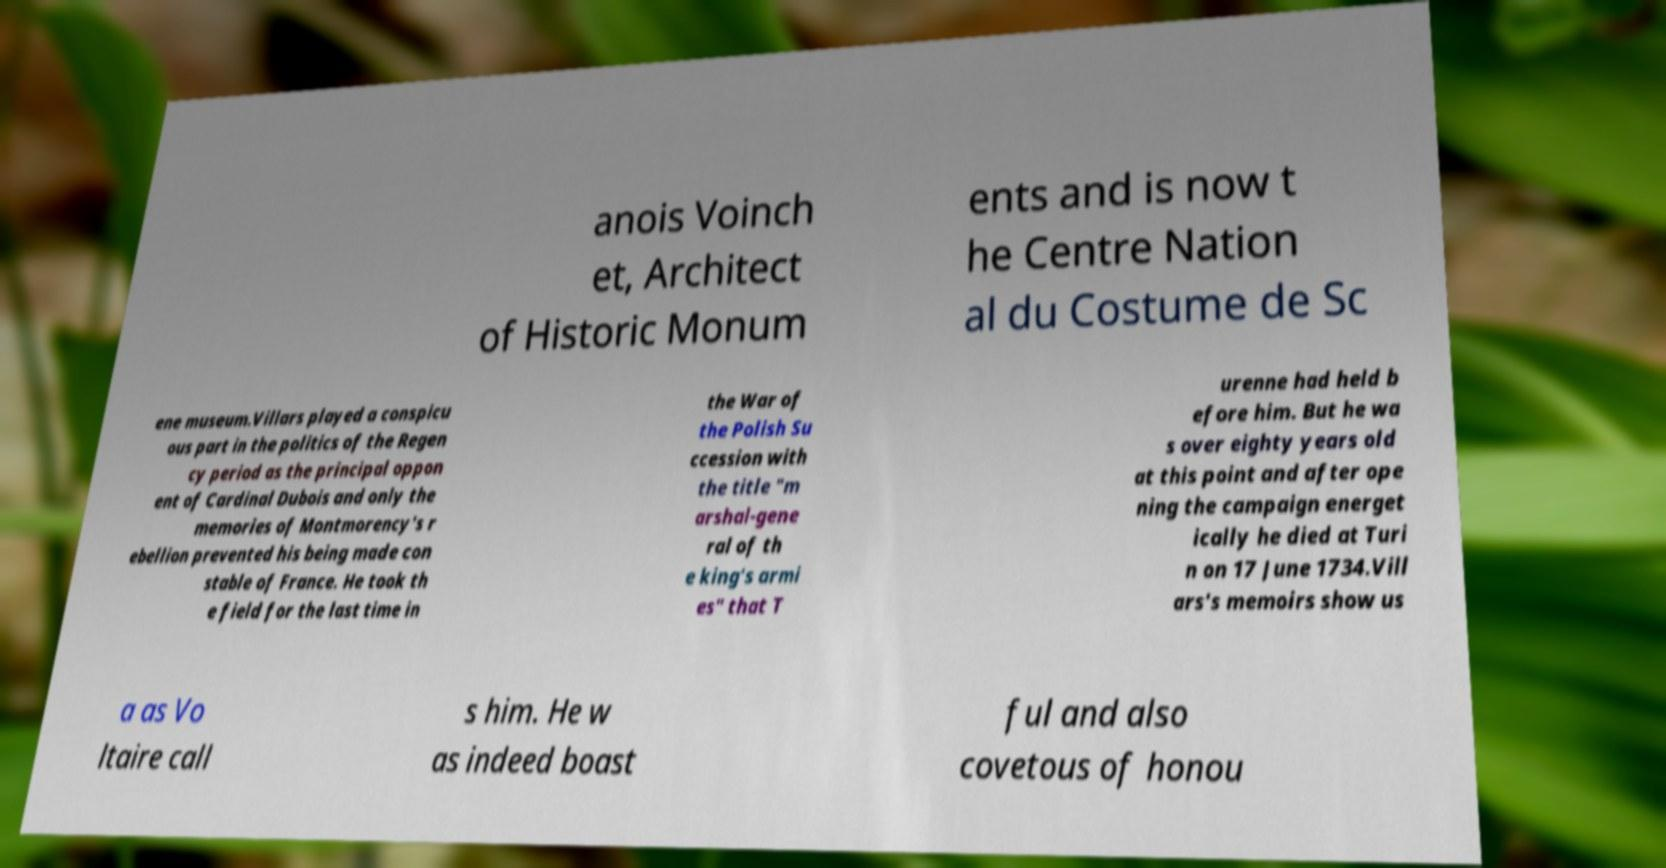Please identify and transcribe the text found in this image. anois Voinch et, Architect of Historic Monum ents and is now t he Centre Nation al du Costume de Sc ene museum.Villars played a conspicu ous part in the politics of the Regen cy period as the principal oppon ent of Cardinal Dubois and only the memories of Montmorency's r ebellion prevented his being made con stable of France. He took th e field for the last time in the War of the Polish Su ccession with the title "m arshal-gene ral of th e king's armi es" that T urenne had held b efore him. But he wa s over eighty years old at this point and after ope ning the campaign energet ically he died at Turi n on 17 June 1734.Vill ars's memoirs show us a as Vo ltaire call s him. He w as indeed boast ful and also covetous of honou 